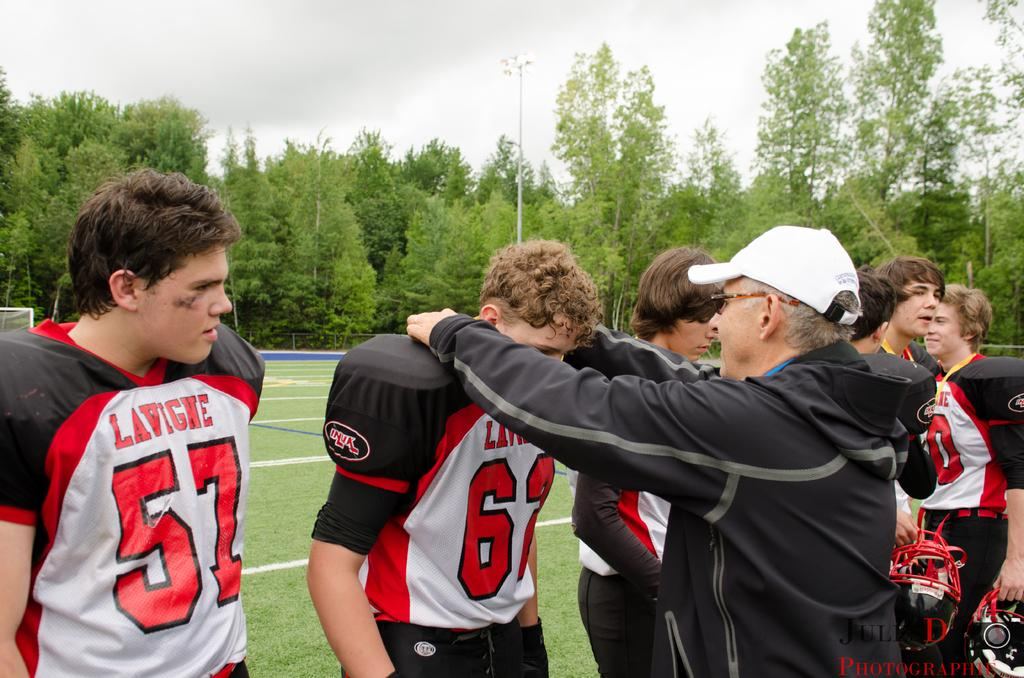<image>
Describe the image concisely. Football players for the team Lavigne on the field. 